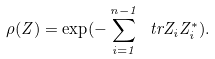<formula> <loc_0><loc_0><loc_500><loc_500>\rho ( Z ) = \exp ( - \sum _ { i = 1 } ^ { n - 1 } \ t r Z _ { i } Z _ { i } ^ { * } ) .</formula> 